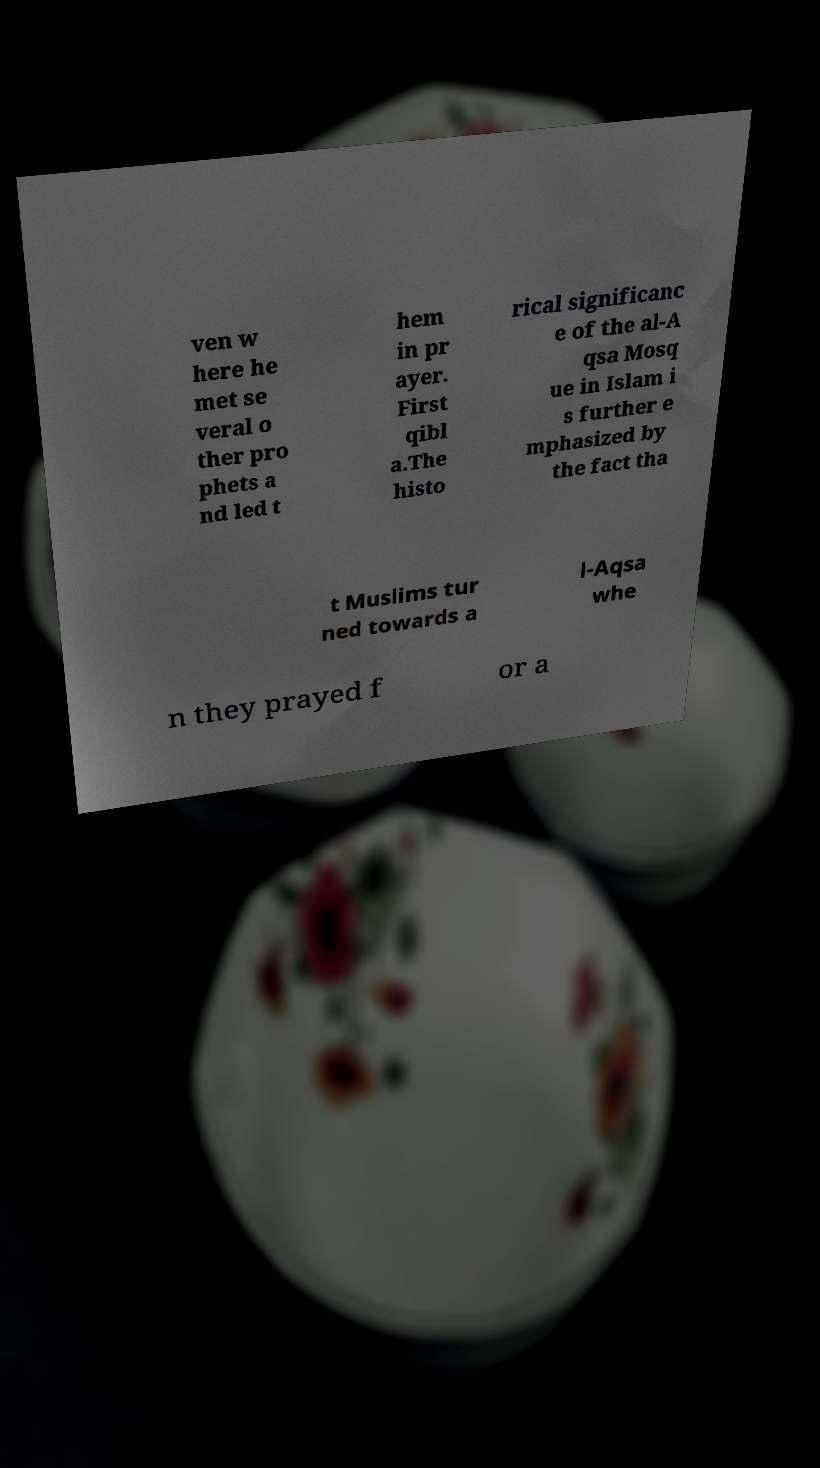Can you read and provide the text displayed in the image?This photo seems to have some interesting text. Can you extract and type it out for me? ven w here he met se veral o ther pro phets a nd led t hem in pr ayer. First qibl a.The histo rical significanc e of the al-A qsa Mosq ue in Islam i s further e mphasized by the fact tha t Muslims tur ned towards a l-Aqsa whe n they prayed f or a 